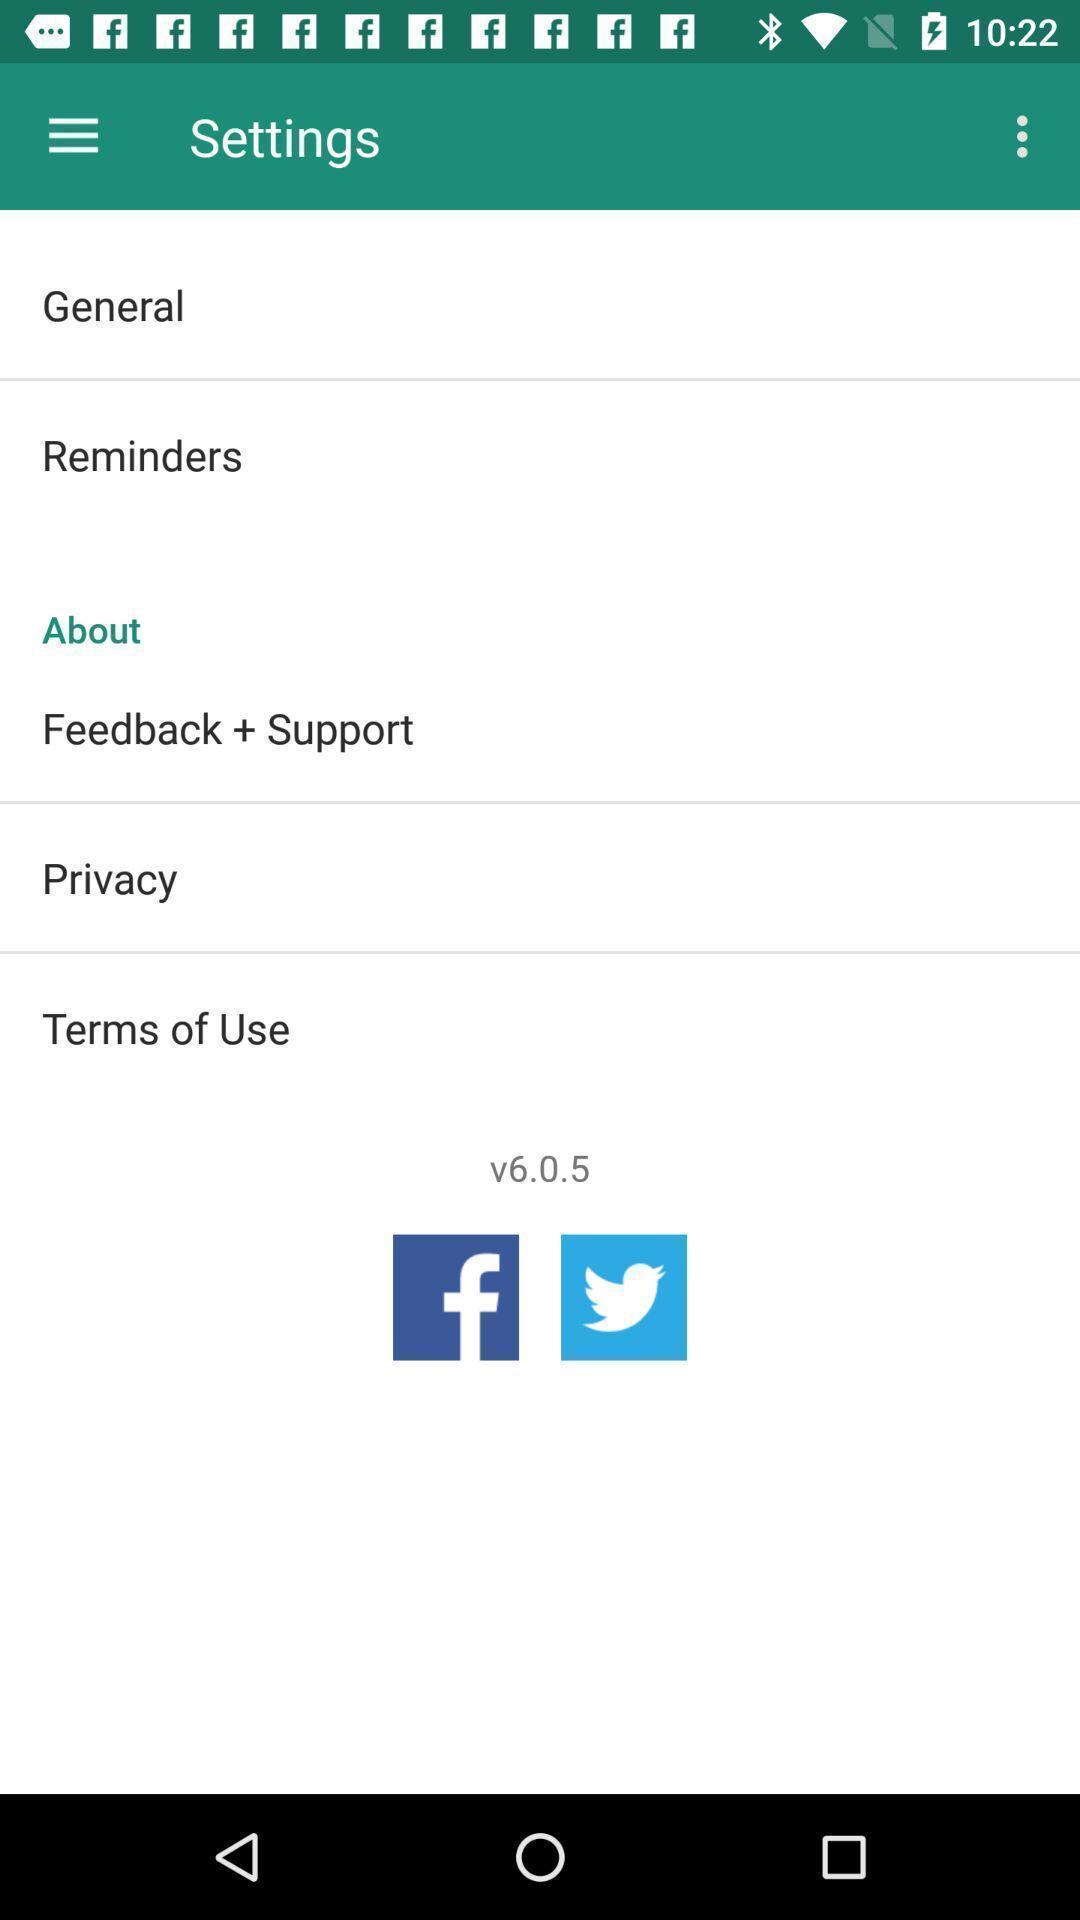What details can you identify in this image? Settings page. 